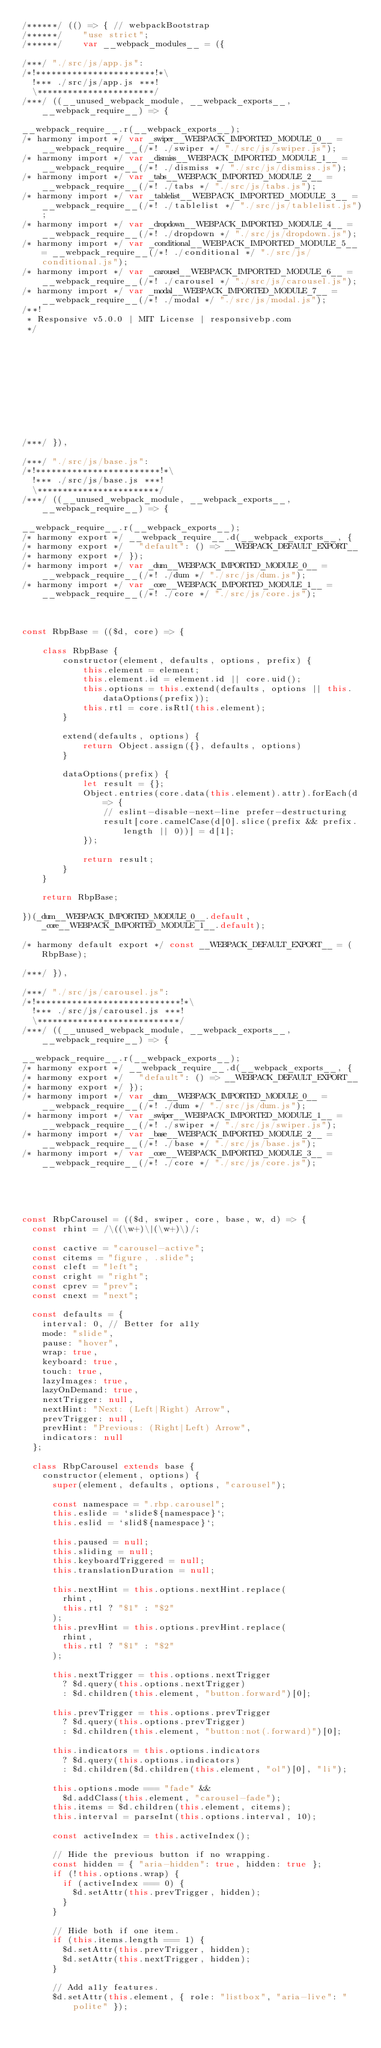<code> <loc_0><loc_0><loc_500><loc_500><_JavaScript_>/******/ (() => { // webpackBootstrap
/******/ 	"use strict";
/******/ 	var __webpack_modules__ = ({

/***/ "./src/js/app.js":
/*!***********************!*\
  !*** ./src/js/app.js ***!
  \***********************/
/***/ ((__unused_webpack_module, __webpack_exports__, __webpack_require__) => {

__webpack_require__.r(__webpack_exports__);
/* harmony import */ var _swiper__WEBPACK_IMPORTED_MODULE_0__ = __webpack_require__(/*! ./swiper */ "./src/js/swiper.js");
/* harmony import */ var _dismiss__WEBPACK_IMPORTED_MODULE_1__ = __webpack_require__(/*! ./dismiss */ "./src/js/dismiss.js");
/* harmony import */ var _tabs__WEBPACK_IMPORTED_MODULE_2__ = __webpack_require__(/*! ./tabs */ "./src/js/tabs.js");
/* harmony import */ var _tablelist__WEBPACK_IMPORTED_MODULE_3__ = __webpack_require__(/*! ./tablelist */ "./src/js/tablelist.js");
/* harmony import */ var _dropdown__WEBPACK_IMPORTED_MODULE_4__ = __webpack_require__(/*! ./dropdown */ "./src/js/dropdown.js");
/* harmony import */ var _conditional__WEBPACK_IMPORTED_MODULE_5__ = __webpack_require__(/*! ./conditional */ "./src/js/conditional.js");
/* harmony import */ var _carousel__WEBPACK_IMPORTED_MODULE_6__ = __webpack_require__(/*! ./carousel */ "./src/js/carousel.js");
/* harmony import */ var _modal__WEBPACK_IMPORTED_MODULE_7__ = __webpack_require__(/*! ./modal */ "./src/js/modal.js");
/**!
 * Responsive v5.0.0 | MIT License | responsivebp.com
 */











/***/ }),

/***/ "./src/js/base.js":
/*!************************!*\
  !*** ./src/js/base.js ***!
  \************************/
/***/ ((__unused_webpack_module, __webpack_exports__, __webpack_require__) => {

__webpack_require__.r(__webpack_exports__);
/* harmony export */ __webpack_require__.d(__webpack_exports__, {
/* harmony export */   "default": () => __WEBPACK_DEFAULT_EXPORT__
/* harmony export */ });
/* harmony import */ var _dum__WEBPACK_IMPORTED_MODULE_0__ = __webpack_require__(/*! ./dum */ "./src/js/dum.js");
/* harmony import */ var _core__WEBPACK_IMPORTED_MODULE_1__ = __webpack_require__(/*! ./core */ "./src/js/core.js");



const RbpBase = (($d, core) => {

    class RbpBase {
        constructor(element, defaults, options, prefix) {
            this.element = element;
            this.element.id = element.id || core.uid();
            this.options = this.extend(defaults, options || this.dataOptions(prefix));
            this.rtl = core.isRtl(this.element);
        }

        extend(defaults, options) {
            return Object.assign({}, defaults, options)
        }

        dataOptions(prefix) {
            let result = {};
            Object.entries(core.data(this.element).attr).forEach(d => {
                // eslint-disable-next-line prefer-destructuring
                result[core.camelCase(d[0].slice(prefix && prefix.length || 0))] = d[1];
            });

            return result;
        }
    }

    return RbpBase;

})(_dum__WEBPACK_IMPORTED_MODULE_0__.default, _core__WEBPACK_IMPORTED_MODULE_1__.default);

/* harmony default export */ const __WEBPACK_DEFAULT_EXPORT__ = (RbpBase);

/***/ }),

/***/ "./src/js/carousel.js":
/*!****************************!*\
  !*** ./src/js/carousel.js ***!
  \****************************/
/***/ ((__unused_webpack_module, __webpack_exports__, __webpack_require__) => {

__webpack_require__.r(__webpack_exports__);
/* harmony export */ __webpack_require__.d(__webpack_exports__, {
/* harmony export */   "default": () => __WEBPACK_DEFAULT_EXPORT__
/* harmony export */ });
/* harmony import */ var _dum__WEBPACK_IMPORTED_MODULE_0__ = __webpack_require__(/*! ./dum */ "./src/js/dum.js");
/* harmony import */ var _swiper__WEBPACK_IMPORTED_MODULE_1__ = __webpack_require__(/*! ./swiper */ "./src/js/swiper.js");
/* harmony import */ var _base__WEBPACK_IMPORTED_MODULE_2__ = __webpack_require__(/*! ./base */ "./src/js/base.js");
/* harmony import */ var _core__WEBPACK_IMPORTED_MODULE_3__ = __webpack_require__(/*! ./core */ "./src/js/core.js");





const RbpCarousel = (($d, swiper, core, base, w, d) => {
  const rhint = /\((\w+)\|(\w+)\)/;

  const cactive = "carousel-active";
  const citems = "figure, .slide";
  const cleft = "left";
  const cright = "right";
  const cprev = "prev";
  const cnext = "next";

  const defaults = {
    interval: 0, // Better for a11y
    mode: "slide",
    pause: "hover",
    wrap: true,
    keyboard: true,
    touch: true,
    lazyImages: true,
    lazyOnDemand: true,
    nextTrigger: null,
    nextHint: "Next: (Left|Right) Arrow",
    prevTrigger: null,
    prevHint: "Previous: (Right|Left) Arrow",
    indicators: null
  };

  class RbpCarousel extends base {
    constructor(element, options) {
      super(element, defaults, options, "carousel");

      const namespace = ".rbp.carousel";
      this.eslide = `slide${namespace}`;
      this.eslid = `slid${namespace}`;

      this.paused = null;
      this.sliding = null;
      this.keyboardTriggered = null;
      this.translationDuration = null;

      this.nextHint = this.options.nextHint.replace(
        rhint,
        this.rtl ? "$1" : "$2"
      );
      this.prevHint = this.options.prevHint.replace(
        rhint,
        this.rtl ? "$1" : "$2"
      );

      this.nextTrigger = this.options.nextTrigger
        ? $d.query(this.options.nextTrigger)
        : $d.children(this.element, "button.forward")[0];

      this.prevTrigger = this.options.prevTrigger
        ? $d.query(this.options.prevTrigger)
        : $d.children(this.element, "button:not(.forward)")[0];

      this.indicators = this.options.indicators
        ? $d.query(this.options.indicators)
        : $d.children($d.children(this.element, "ol")[0], "li");

      this.options.mode === "fade" &&
        $d.addClass(this.element, "carousel-fade");
      this.items = $d.children(this.element, citems);
      this.interval = parseInt(this.options.interval, 10);

      const activeIndex = this.activeIndex();

      // Hide the previous button if no wrapping.
      const hidden = { "aria-hidden": true, hidden: true };
      if (!this.options.wrap) {
        if (activeIndex === 0) {
          $d.setAttr(this.prevTrigger, hidden);
        }
      }

      // Hide both if one item.
      if (this.items.length === 1) {
        $d.setAttr(this.prevTrigger, hidden);
        $d.setAttr(this.nextTrigger, hidden);
      }

      // Add a11y features.
      $d.setAttr(this.element, { role: "listbox", "aria-live": "polite" });
</code> 